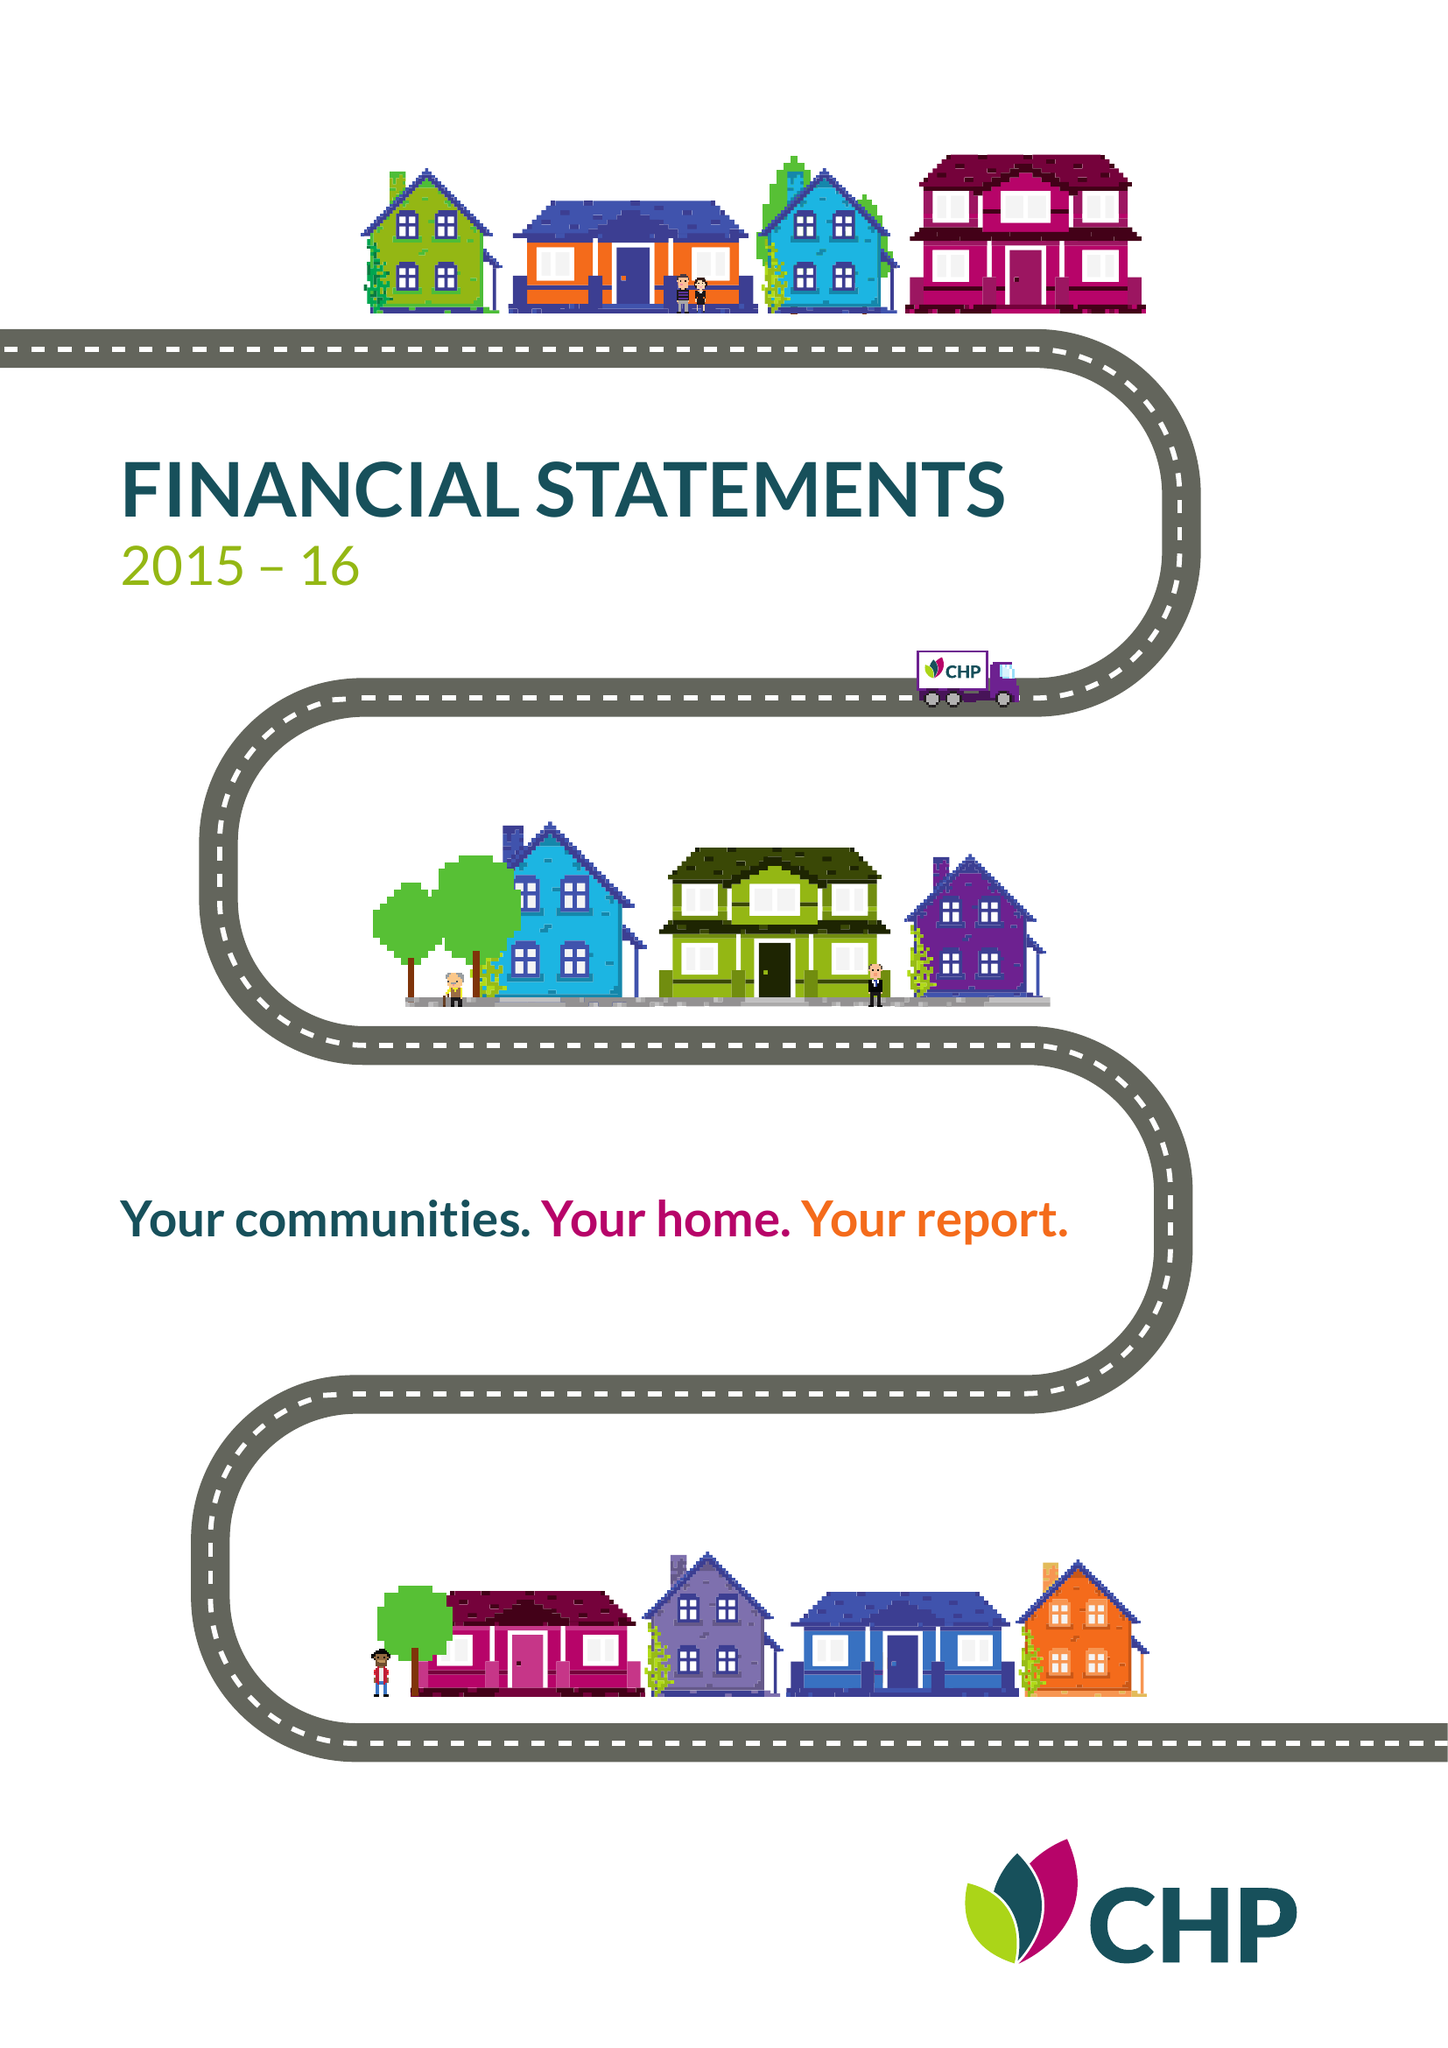What is the value for the income_annually_in_british_pounds?
Answer the question using a single word or phrase. 51340000.00 